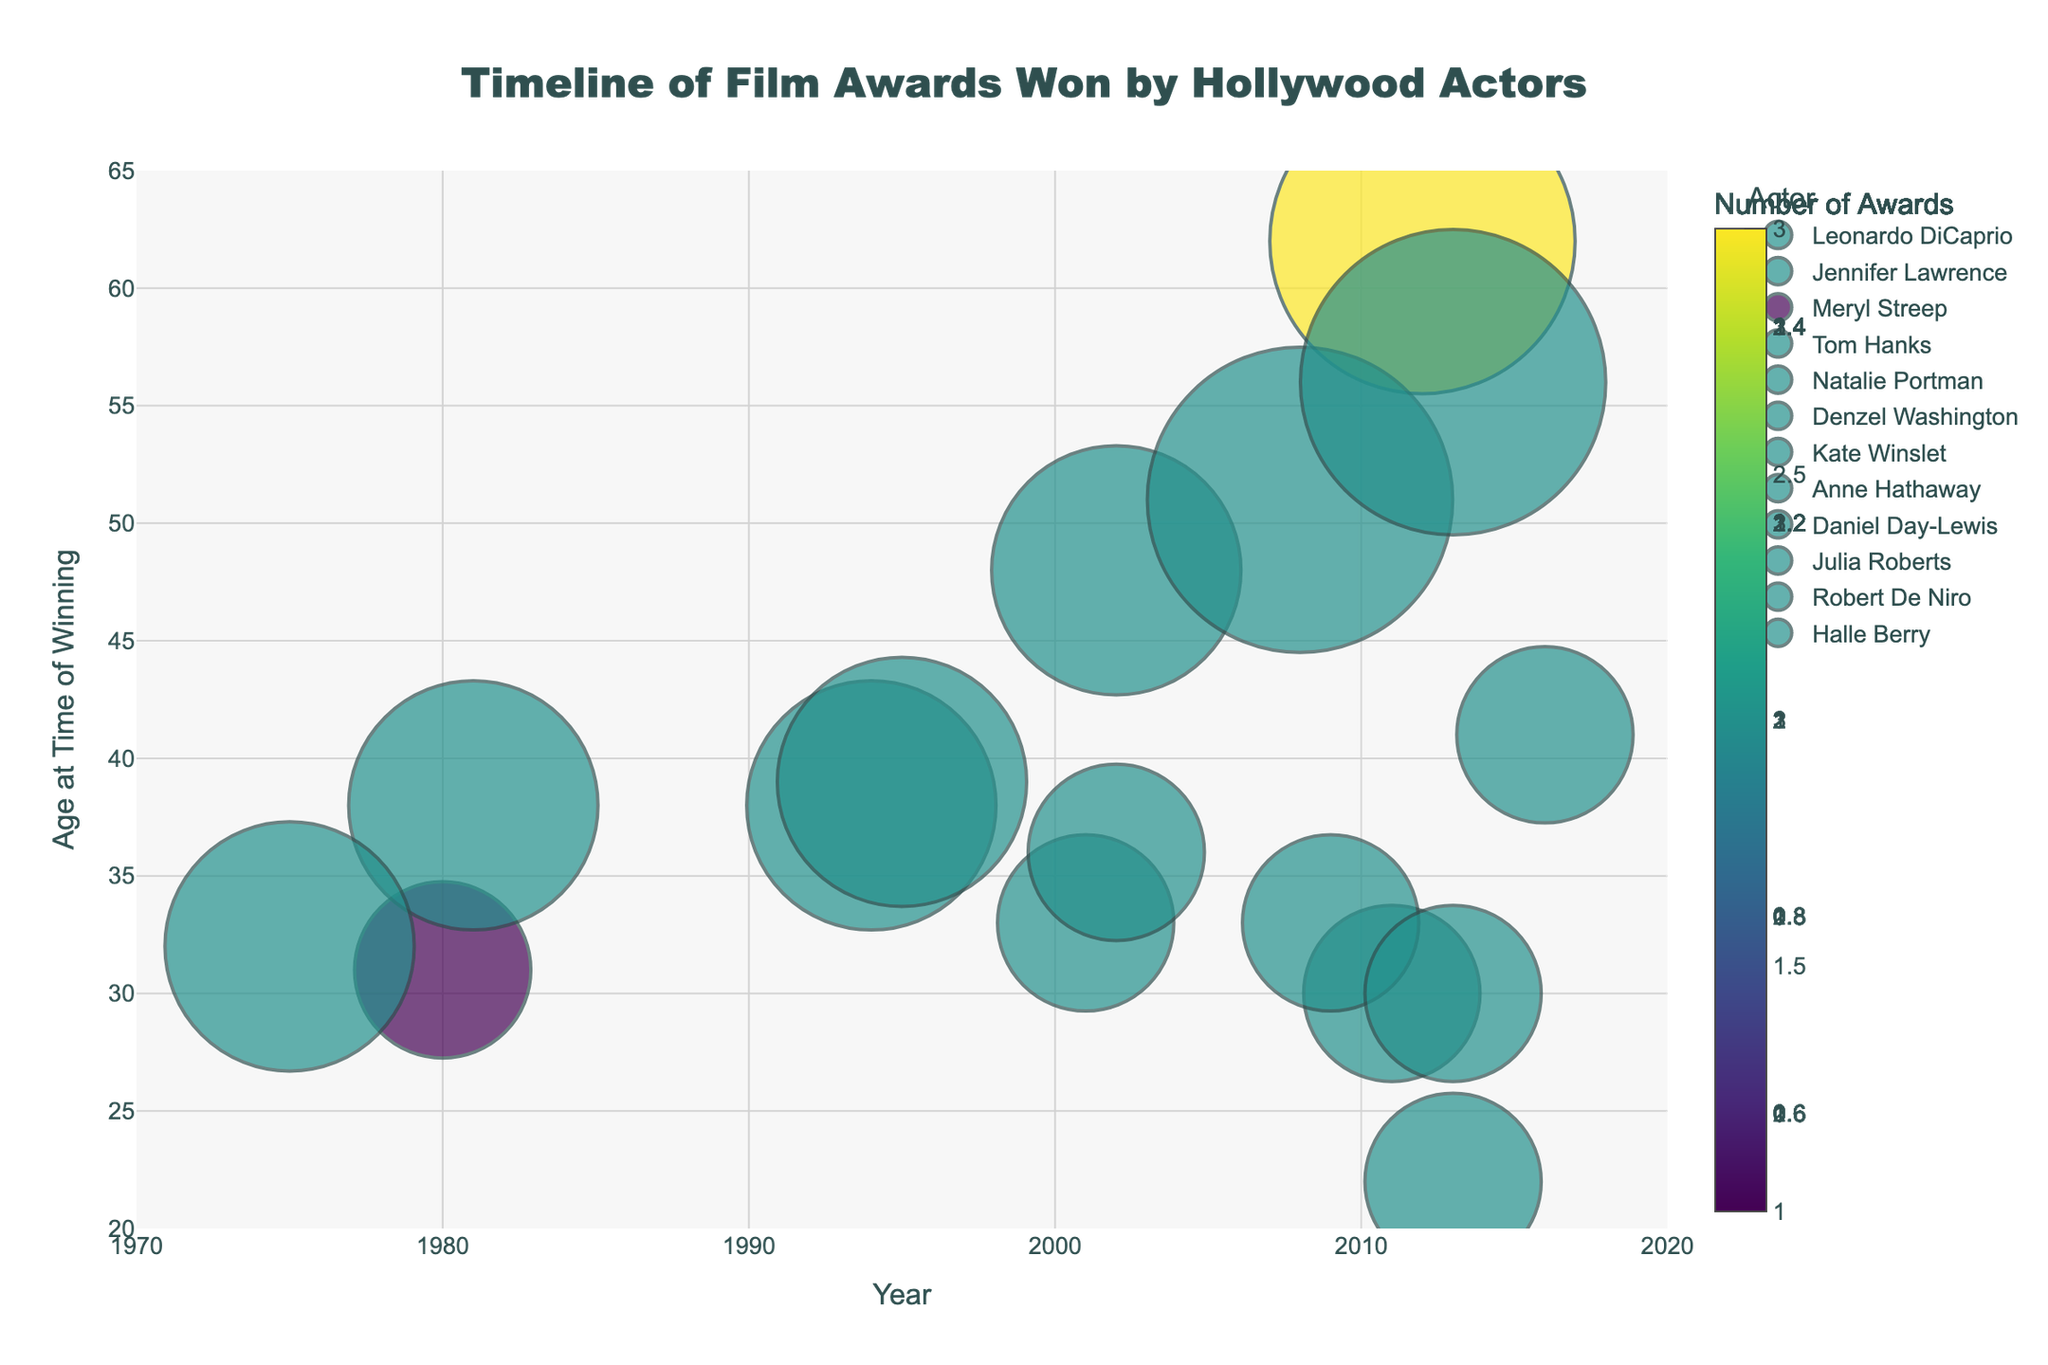What is the title of the figure? The title is at the top center of the figure and it reads "Timeline of Film Awards Won by Hollywood Actors".
Answer: Timeline of Film Awards Won by Hollywood Actors Who is the youngest actor to win an award, and at what age? Look at the y-axis for the lowest age value. Jennifer Lawrence's award in 2013 at age 22 marks her as the youngest.
Answer: Jennifer Lawrence, 22 Which actor appears to have won the most awards? Look for the largest bubbles as they represent the number of awards. Meryl Streep and Daniel Day-Lewis have the largest bubbles, indicating they have won the most awards.
Answer: Meryl Streep and Daniel Day-Lewis How many awards did Tom Hanks win between 1994 and 1995? Identify Tom Hanks' bubbles and count the number of awards in these years. He has one award for each year translating to 2 awards in total.
Answer: 2 Which year had the presence of the highest number of different actors winning awards? By gauging all the bubbles spread over the years, the year 2013 has the highest number of individual markers, indicating more actors won awards that year.
Answer: 2013 Which actor won an award at the oldest age and at what age? Look for the y-axis for the highest age value. Identify the actor and their age at that point. Meryl Streep in 2012 at age 62 indicates she was the oldest.
Answer: Meryl Streep, 62 How many years after Meryl Streep won her first Oscar did she win her third Oscar? Meryl Streep's first win was in 1980 and her third was in 2012. Subtracting these years gives the time span.
Answer: 32 years Compare the age difference between Leonardo DiCaprio’s and Natalie Portman’s Oscar wins. Leonardo DiCaprio won at age 41 in 2016, and Natalie Portman won at age 30 in 2011. The difference is 11 years.
Answer: 11 years Which actors have won multiple awards, and how can you tell? Actors with multiple awards have larger, specifically colored bubbles associated with them, indicating the number of awards. Examples include Tom Hanks, Meryl Streep, Denzel Washington, Robert De Niro, and Daniel Day-Lewis.
Answer: Tom Hanks, Meryl Streep, Denzel Washington, Robert De Niro, Daniel Day-Lewis For each actor who won awards multiple times, identify the film titles of the awards they won. Check the hover text or corresponding markers for each actor with multiple awards. Meryl Streep won for "Kramer vs. Kramer" (1980), "The Iron Lady" (2012). Tom Hanks for "Forrest Gump" (1994), "Apollo 13" (1995). Denzel Washington for "Training Day" (2002). Robert De Niro for "Raging Bull" (1981), "The Godfather Part II" (1975). Daniel Day-Lewis for "There Will Be Blood" (2008), "Lincoln" (2013).
Answer: Meryl Streep: "Kramer vs. Kramer", "The Iron Lady"; Tom Hanks: "Forrest Gump", "Apollo 13"; Denzel Washington: "Training Day"; Robert De Niro: "Raging Bull", "The Godfather Part II"; Daniel Day-Lewis: "There Will Be Blood", "Lincoln" 